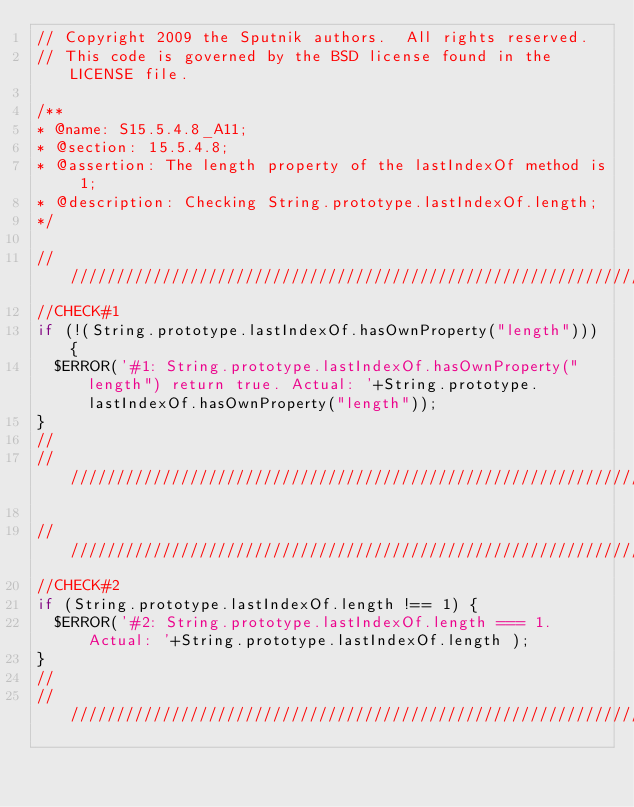<code> <loc_0><loc_0><loc_500><loc_500><_JavaScript_>// Copyright 2009 the Sputnik authors.  All rights reserved.
// This code is governed by the BSD license found in the LICENSE file.

/**
* @name: S15.5.4.8_A11;
* @section: 15.5.4.8;
* @assertion: The length property of the lastIndexOf method is 1;
* @description: Checking String.prototype.lastIndexOf.length;
*/

//////////////////////////////////////////////////////////////////////////////
//CHECK#1
if (!(String.prototype.lastIndexOf.hasOwnProperty("length"))) {
  $ERROR('#1: String.prototype.lastIndexOf.hasOwnProperty("length") return true. Actual: '+String.prototype.lastIndexOf.hasOwnProperty("length"));
}
//
//////////////////////////////////////////////////////////////////////////////

//////////////////////////////////////////////////////////////////////////////
//CHECK#2
if (String.prototype.lastIndexOf.length !== 1) {
  $ERROR('#2: String.prototype.lastIndexOf.length === 1. Actual: '+String.prototype.lastIndexOf.length );
}
//
//////////////////////////////////////////////////////////////////////////////
</code> 